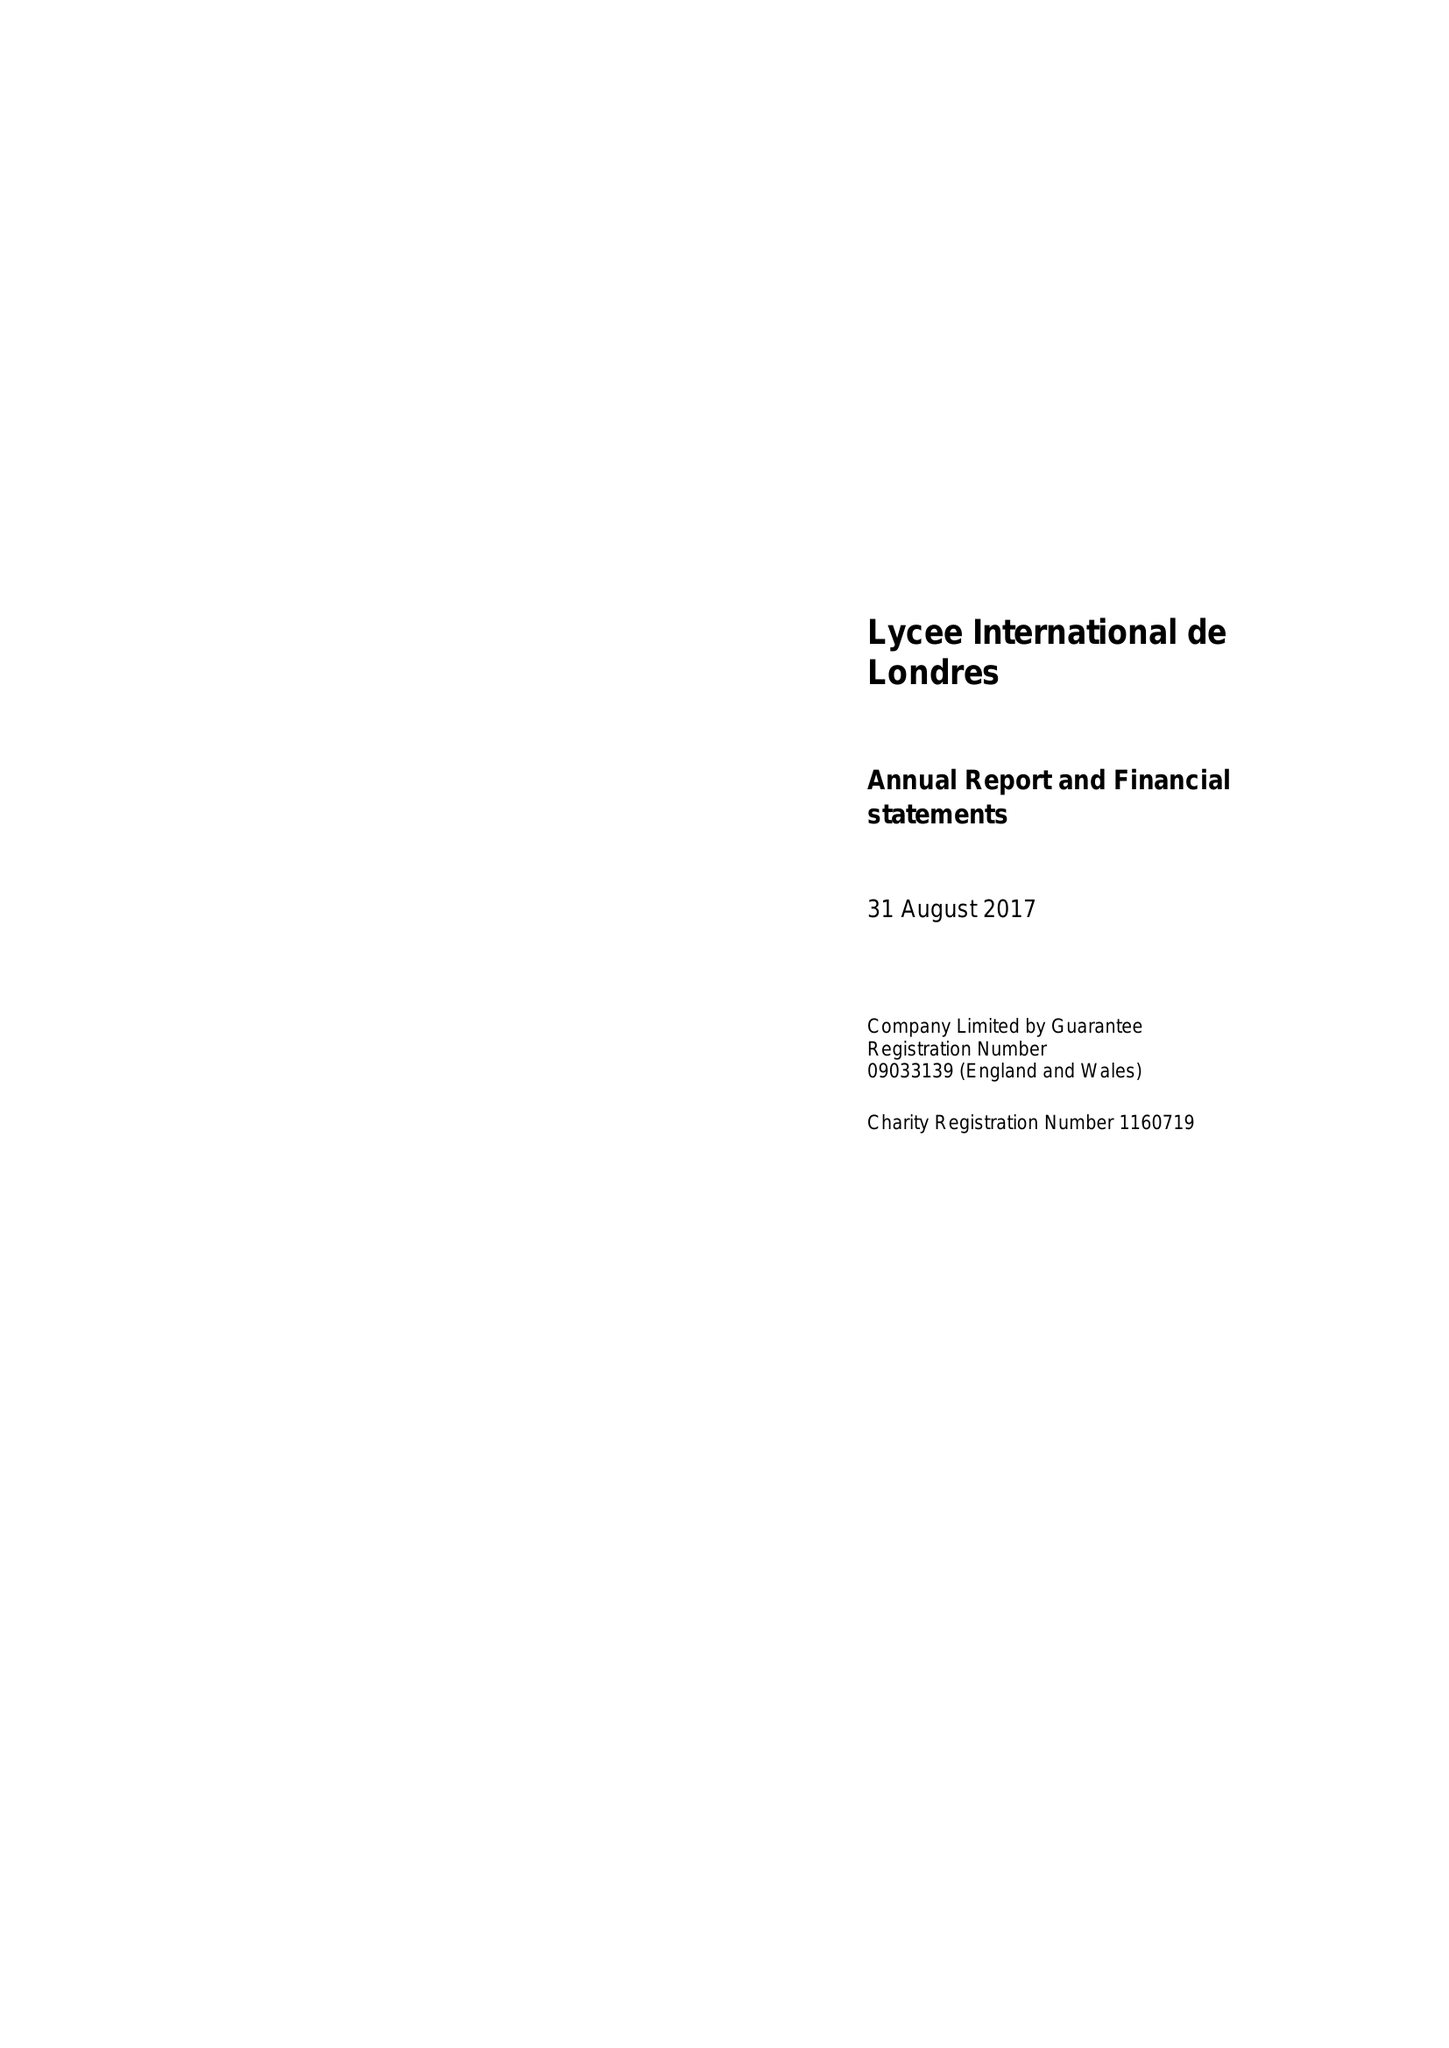What is the value for the income_annually_in_british_pounds?
Answer the question using a single word or phrase. 8716032.00 